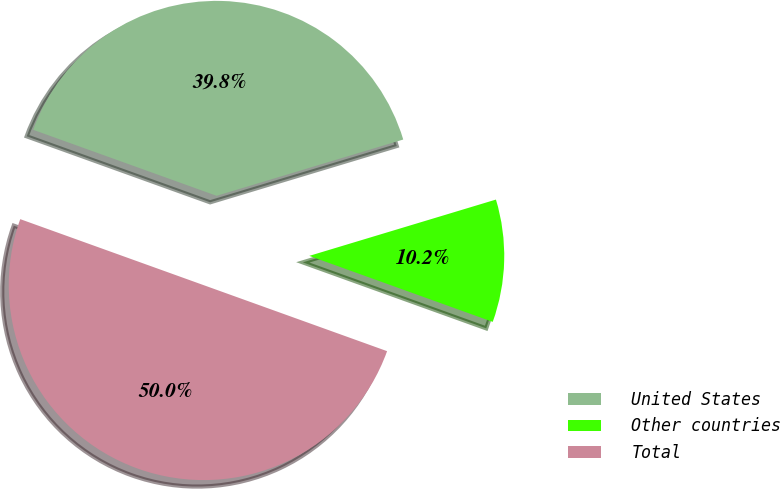Convert chart to OTSL. <chart><loc_0><loc_0><loc_500><loc_500><pie_chart><fcel>United States<fcel>Other countries<fcel>Total<nl><fcel>39.84%<fcel>10.16%<fcel>50.0%<nl></chart> 